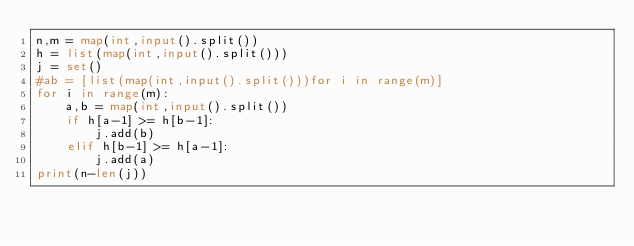Convert code to text. <code><loc_0><loc_0><loc_500><loc_500><_Python_>n,m = map(int,input().split())
h = list(map(int,input().split()))
j = set()
#ab = [list(map(int,input().split()))for i in range(m)]
for i in range(m):
    a,b = map(int,input().split())
    if h[a-1] >= h[b-1]:
        j.add(b)
    elif h[b-1] >= h[a-1]:
        j.add(a)
print(n-len(j))




</code> 